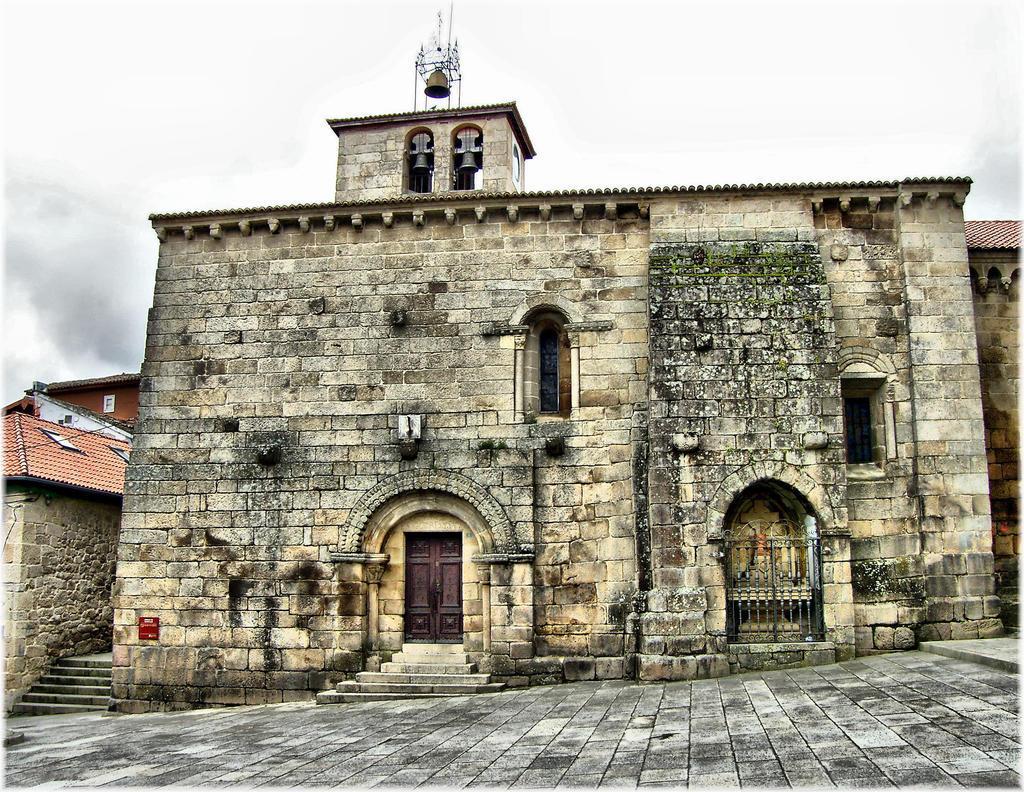Could you give a brief overview of what you see in this image? At the bottom, we see the pavement. In the middle, we see a castle or a building. We see the staircase, railing and a door in brown color. On top of the building, we see a bell and the poles. On the left side, we see a building with a brown color roof. Beside that, we see the staircase. At the top, we see the sky. 